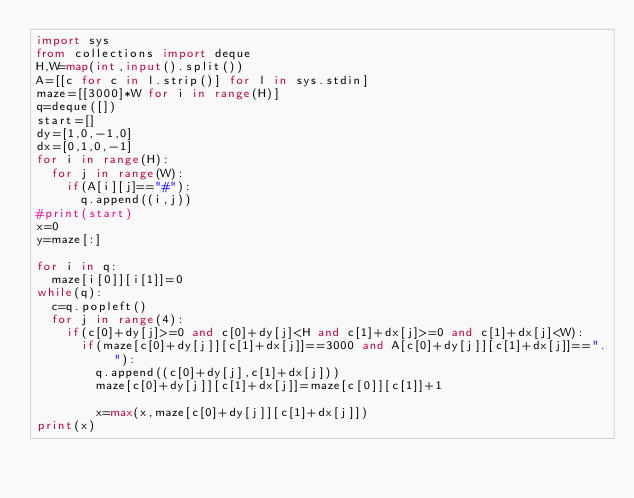<code> <loc_0><loc_0><loc_500><loc_500><_Python_>import sys
from collections import deque
H,W=map(int,input().split())
A=[[c for c in l.strip()] for l in sys.stdin]
maze=[[3000]*W for i in range(H)]
q=deque([])
start=[]
dy=[1,0,-1,0]
dx=[0,1,0,-1]
for i in range(H):
  for j in range(W):
    if(A[i][j]=="#"):
      q.append((i,j))
#print(start)
x=0
y=maze[:]

for i in q:
  maze[i[0]][i[1]]=0
while(q):
  c=q.popleft()
  for j in range(4):
    if(c[0]+dy[j]>=0 and c[0]+dy[j]<H and c[1]+dx[j]>=0 and c[1]+dx[j]<W):
      if(maze[c[0]+dy[j]][c[1]+dx[j]]==3000 and A[c[0]+dy[j]][c[1]+dx[j]]=="."):
        q.append((c[0]+dy[j],c[1]+dx[j]))
        maze[c[0]+dy[j]][c[1]+dx[j]]=maze[c[0]][c[1]]+1
        
        x=max(x,maze[c[0]+dy[j]][c[1]+dx[j]])
print(x)
</code> 